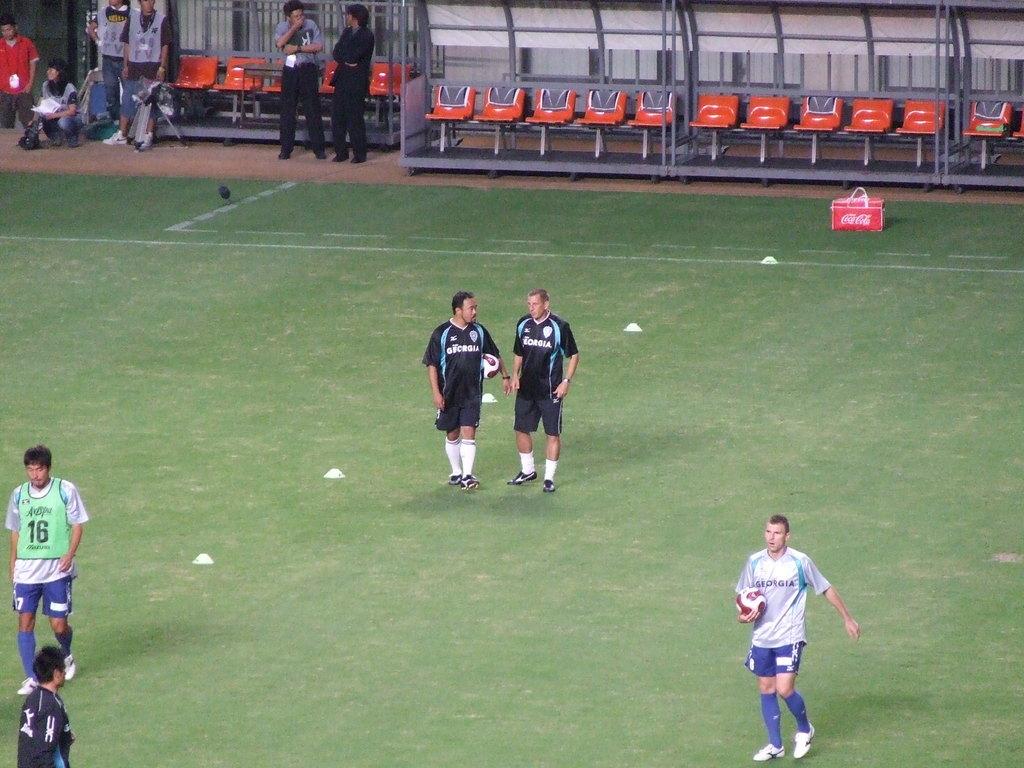What number is the player on the left?
Keep it short and to the point. 16. What is on the cooler?
Ensure brevity in your answer.  Coca cola. 